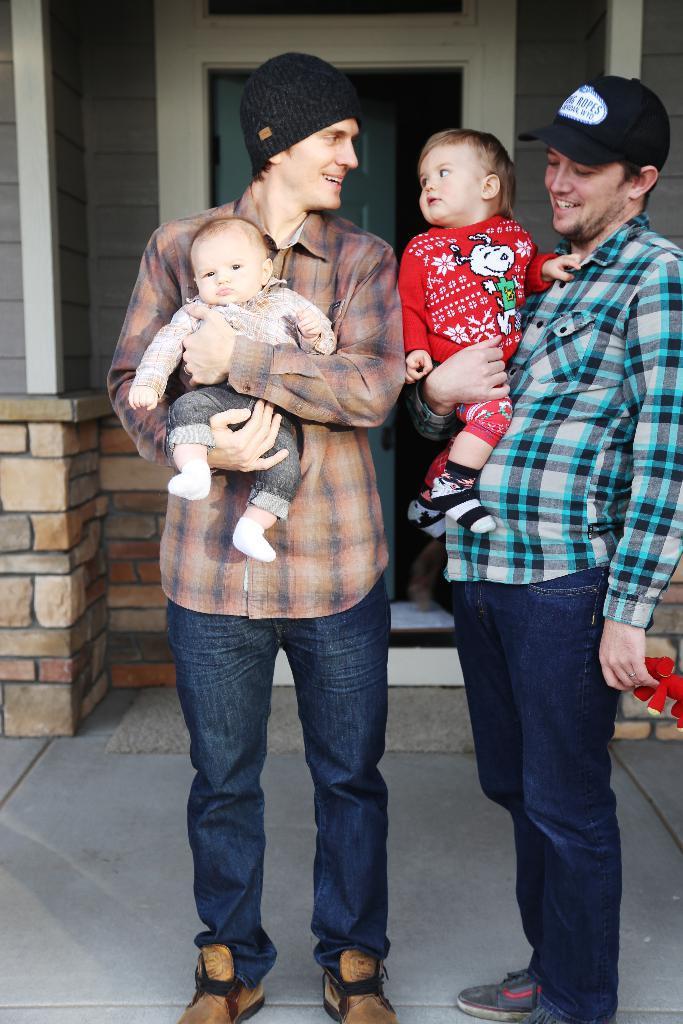Describe this image in one or two sentences. In this image I can see the group of people with different color dresses. I can see two people wearing the caps. In the background I can see the house. 